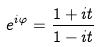Convert formula to latex. <formula><loc_0><loc_0><loc_500><loc_500>e ^ { i \varphi } = \frac { 1 + i t } { 1 - i t }</formula> 